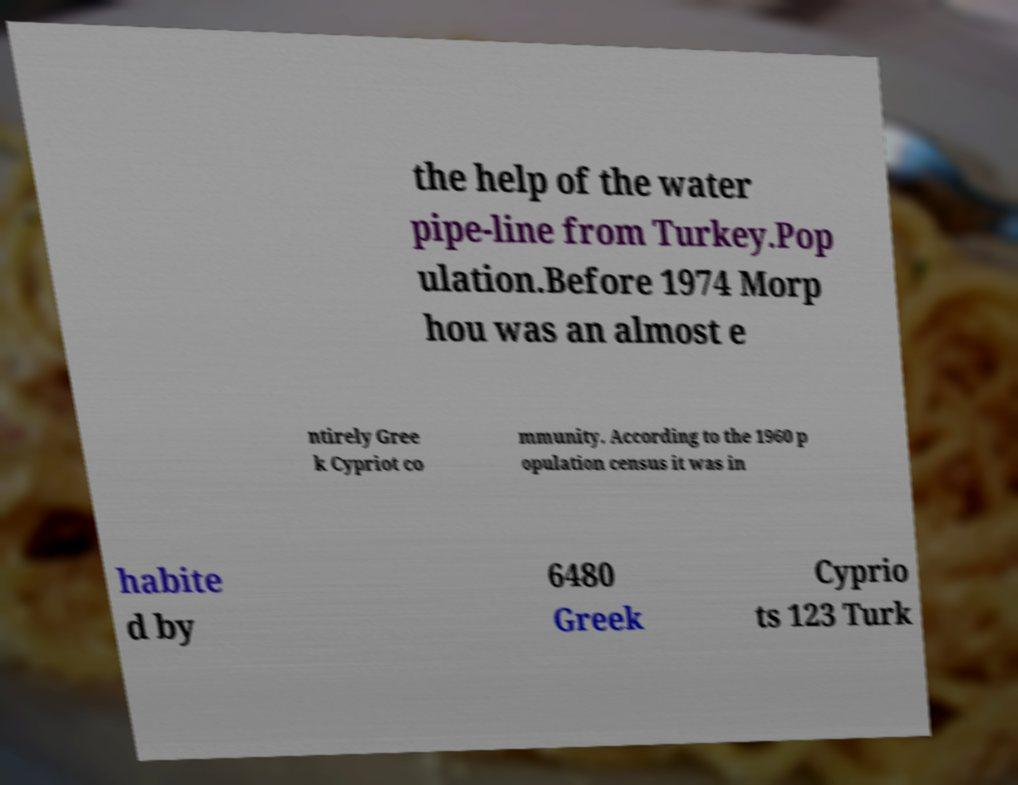There's text embedded in this image that I need extracted. Can you transcribe it verbatim? the help of the water pipe-line from Turkey.Pop ulation.Before 1974 Morp hou was an almost e ntirely Gree k Cypriot co mmunity. According to the 1960 p opulation census it was in habite d by 6480 Greek Cyprio ts 123 Turk 